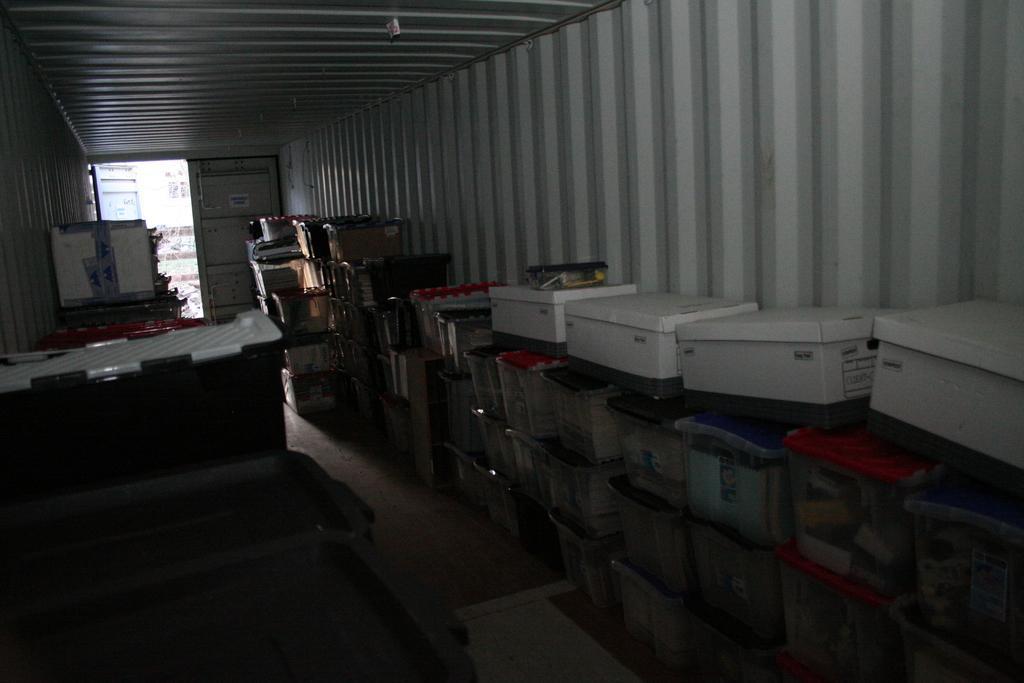Describe this image in one or two sentences. This image is taken inside the shed. In this image there are many boxes and we can see containers. At the bottom there is a floor. In the background there is a door. 